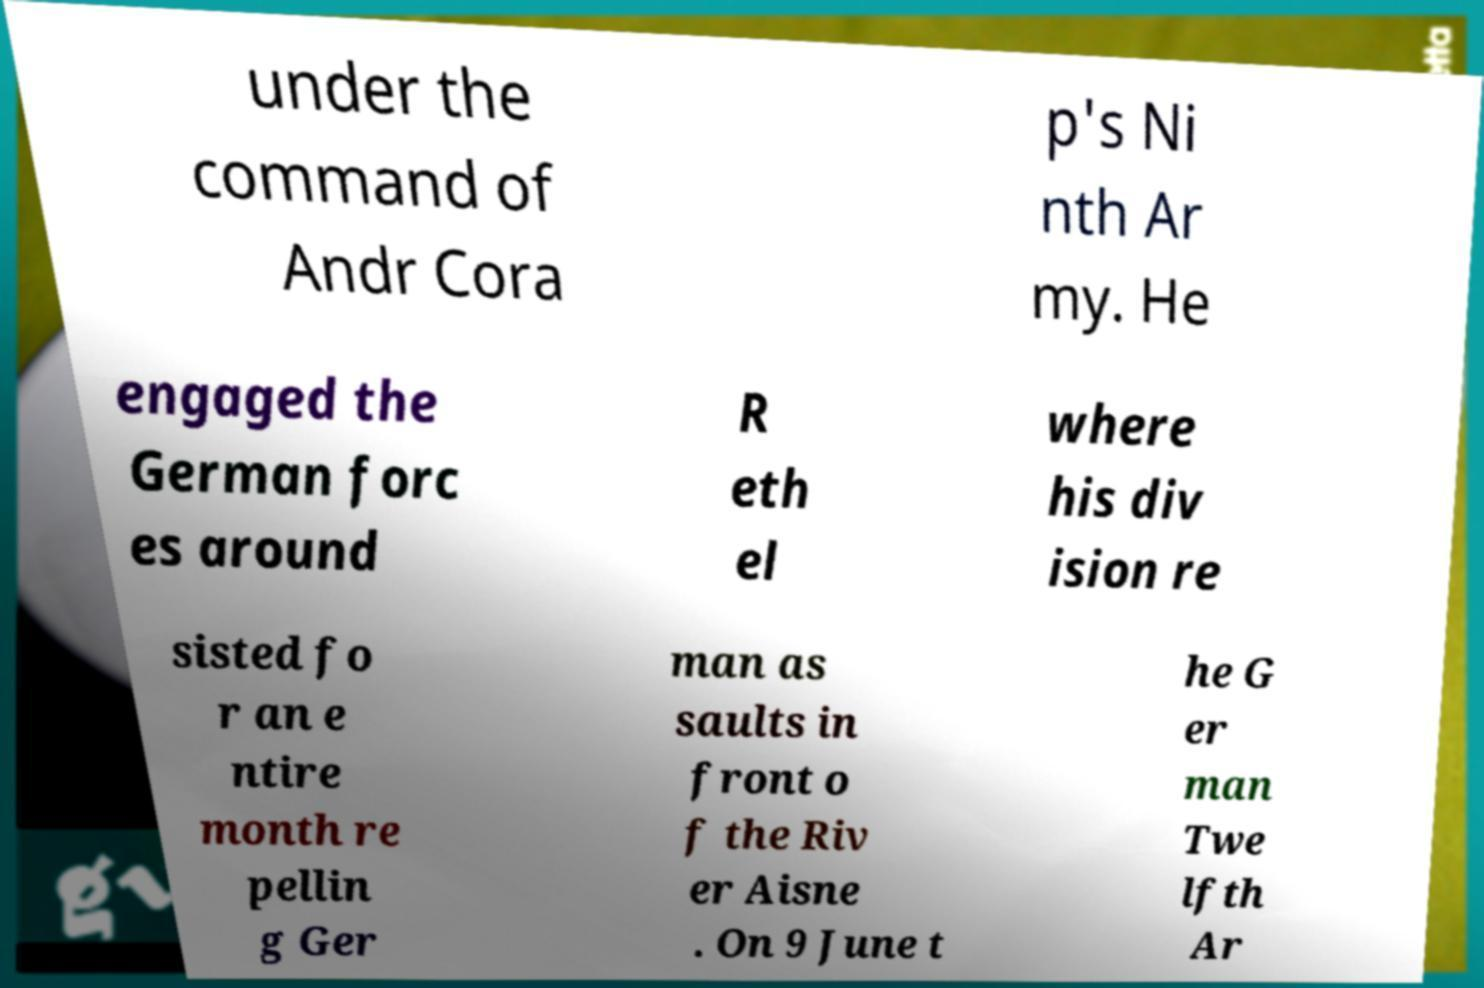There's text embedded in this image that I need extracted. Can you transcribe it verbatim? under the command of Andr Cora p's Ni nth Ar my. He engaged the German forc es around R eth el where his div ision re sisted fo r an e ntire month re pellin g Ger man as saults in front o f the Riv er Aisne . On 9 June t he G er man Twe lfth Ar 